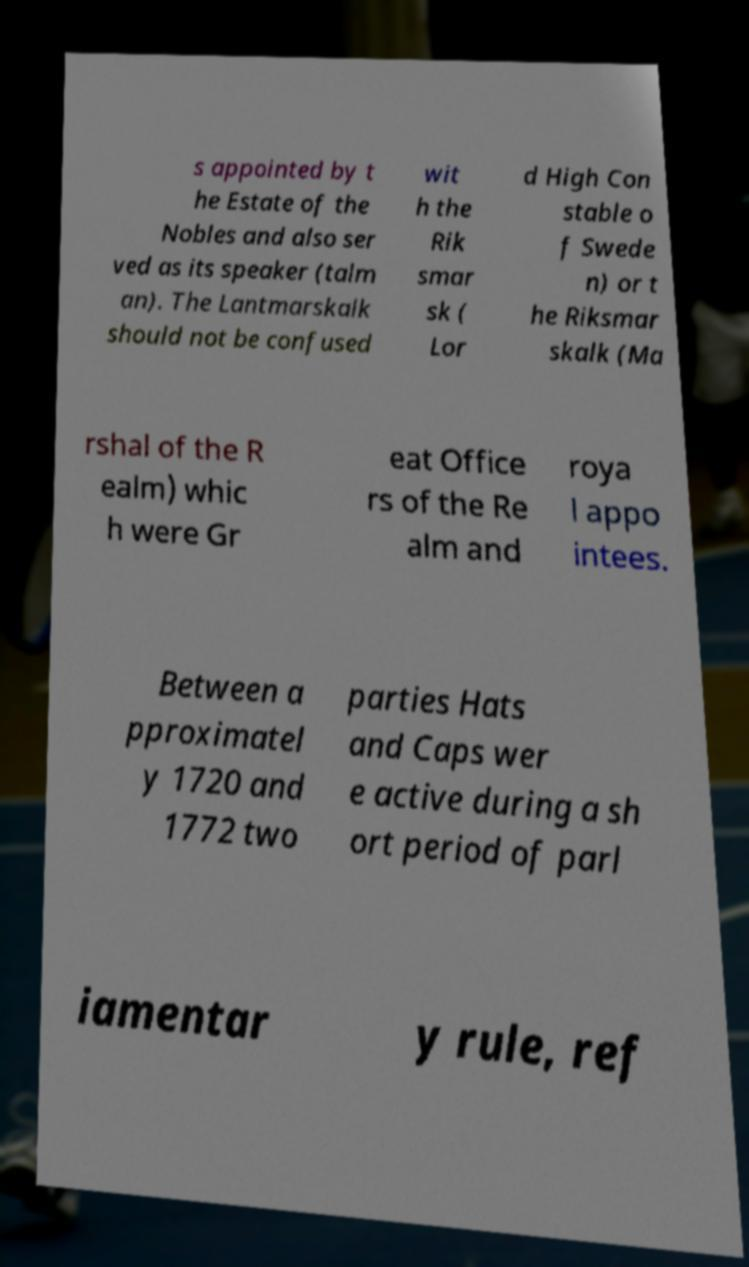For documentation purposes, I need the text within this image transcribed. Could you provide that? s appointed by t he Estate of the Nobles and also ser ved as its speaker (talm an). The Lantmarskalk should not be confused wit h the Rik smar sk ( Lor d High Con stable o f Swede n) or t he Riksmar skalk (Ma rshal of the R ealm) whic h were Gr eat Office rs of the Re alm and roya l appo intees. Between a pproximatel y 1720 and 1772 two parties Hats and Caps wer e active during a sh ort period of parl iamentar y rule, ref 